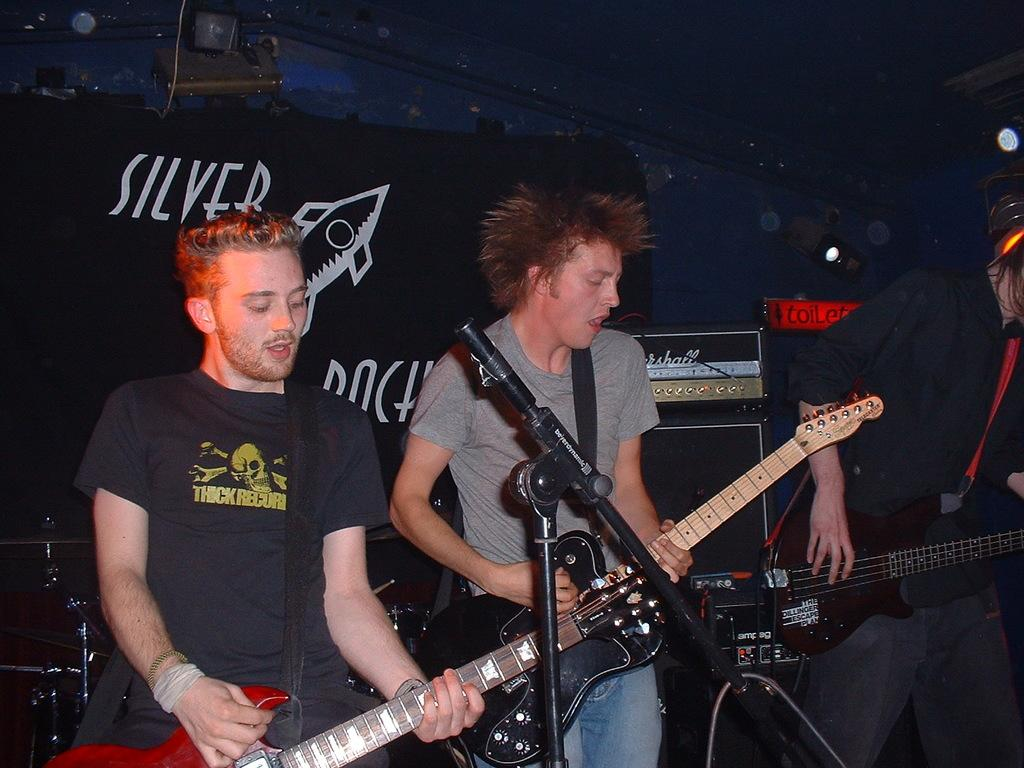Who or what is present in the image? There are people in the image. What are the people doing in the image? The people are standing and holding guitars. What object is in front of the people? There is a microphone (mic) in front of them. What type of grain can be seen growing in the background of the image? There is no grain visible in the image; it features people holding guitars and standing near a microphone. 